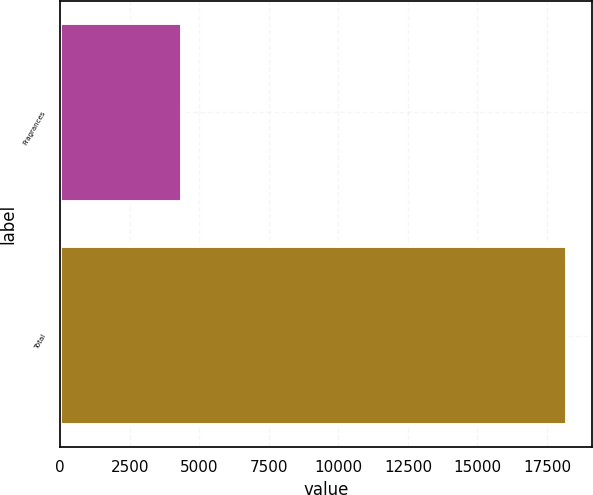Convert chart. <chart><loc_0><loc_0><loc_500><loc_500><bar_chart><fcel>Fragrances<fcel>Total<nl><fcel>4396<fcel>18212<nl></chart> 